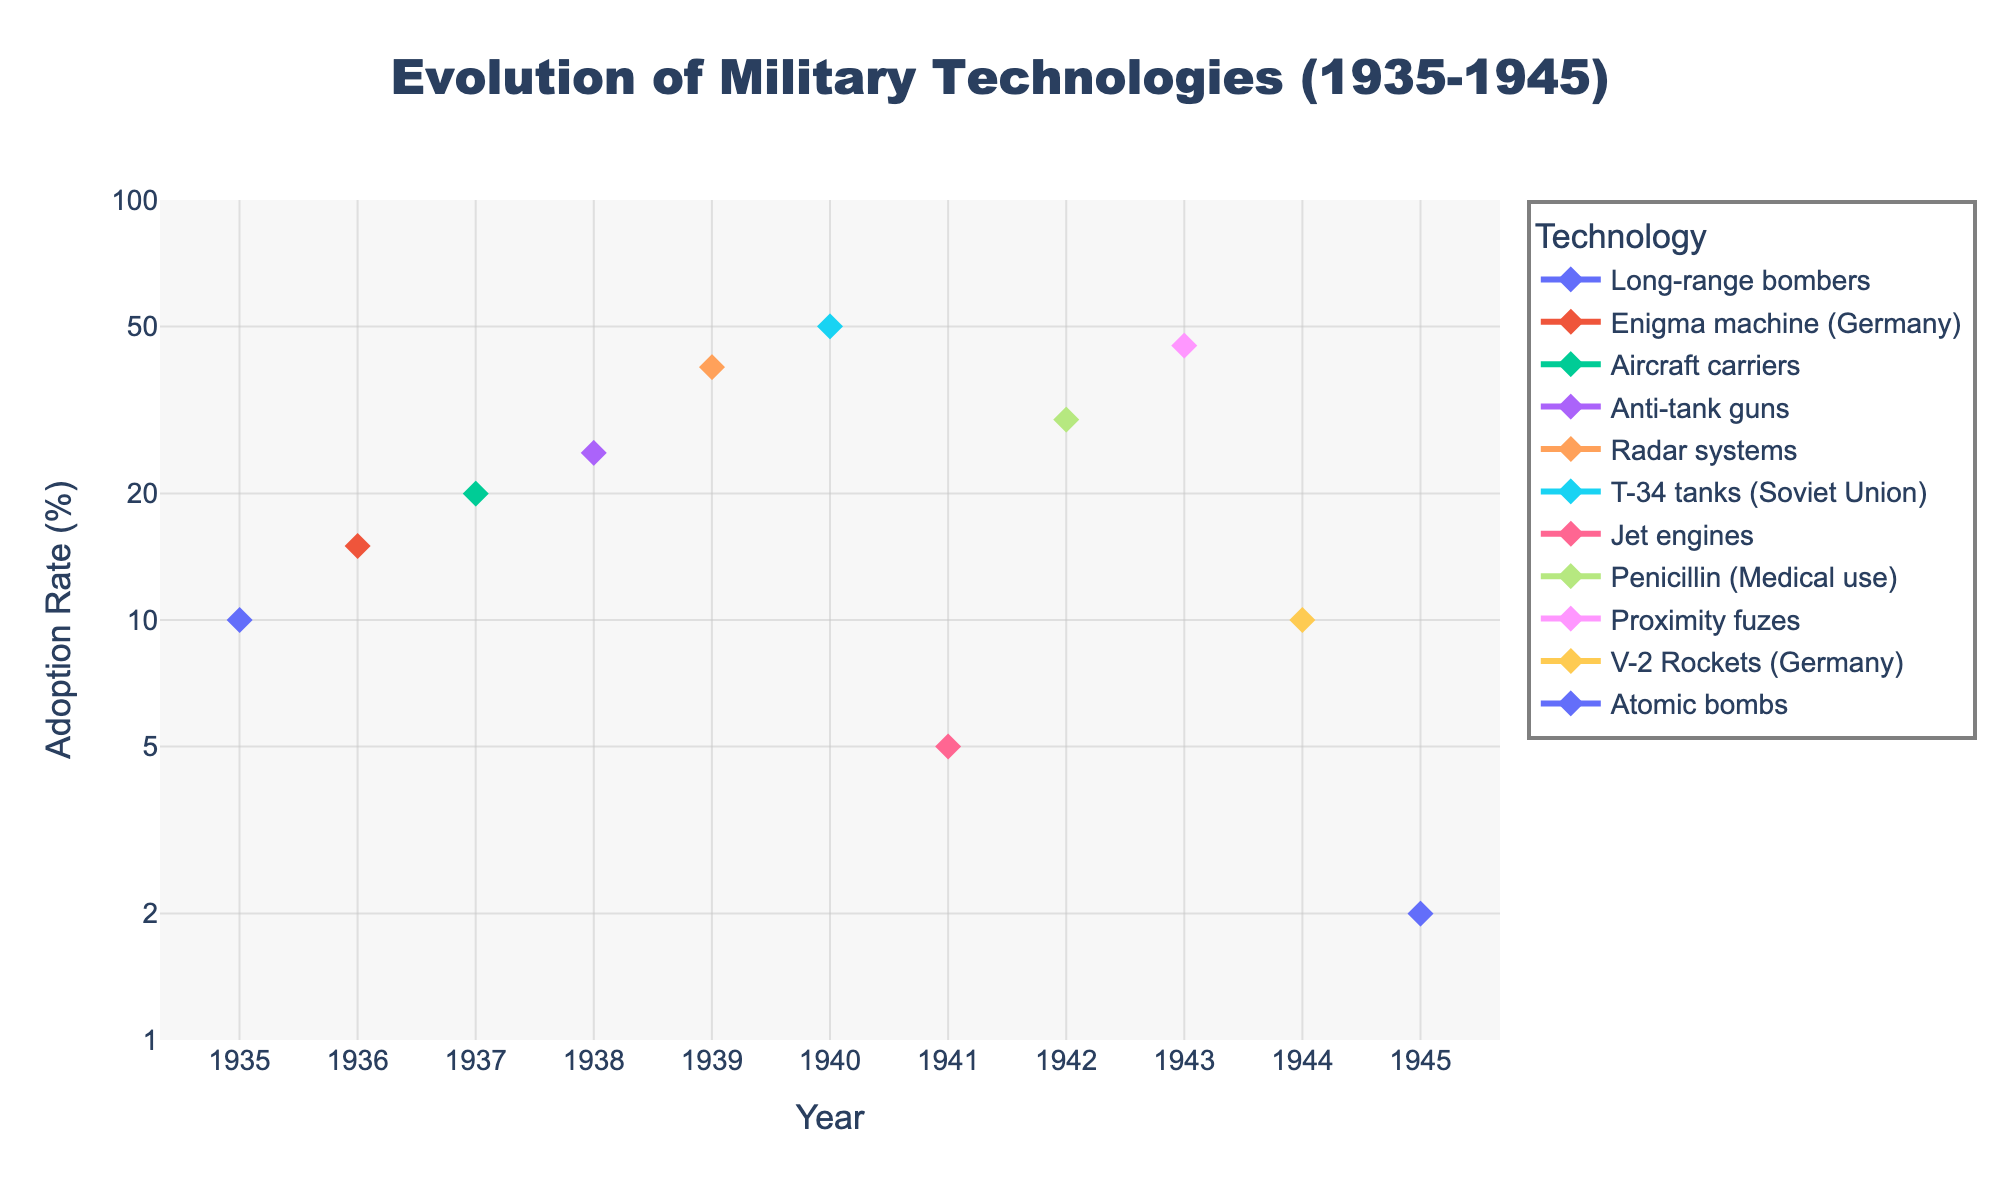What is the title of the figure? The title of the figure is positioned prominently at the top and reads, 'Evolution of Military Technologies (1935-1945)'.
Answer: Evolution of Military Technologies (1935-1945) Which technology had the highest adoption rate in 1940? In 1940, the T-34 tanks (Soviet Union) had the highest adoption rate. This can be identified by checking the adoption rates for all technologies in the year 1940 and noting that T-34 tanks have the maximum value.
Answer: T-34 tanks (Soviet Union) How many technologies are plotted in the figure? The figure shows data for multiple technologies over time. By counting the unique technologies listed, we find there are eleven different technologies.
Answer: Eleven Which technology had an adoption rate of 50% and in which year? By checking the adoption rates, we find that the T-34 tanks (Soviet Union) had an adoption rate of 50%. This occurred in the year 1940.
Answer: T-34 tanks (Soviet Union), 1940 What is the adoption rate of radar systems in 1939? In 1939, radar systems had an adoption rate of 40%. This information is obtained directly from the data list.
Answer: 40% What was the adoption rate of the Enigma machine in 1936, and how does it compare to the adoption rate of V-2 Rockets in 1944? The adoption rate for the Enigma machine in 1936 was 15%. In 1944, the adoption rate for V-2 Rockets was 10%. Comparing the two values, the Enigma machine had a higher adoption rate than V-2 Rockets.
Answer: Enigma machine: 15%, V-2 Rockets: 10% What is the range of the y-axis in this plot? The y-axis uses a logarithmic scale with a range from 1 to 100. This can be checked by examining the y-axis labels and settings.
Answer: 1 to 100 Which year saw the introduction of the atomic bomb, and what was its adoption rate? The figure indicates that the atomic bomb was introduced in 1945 with an adoption rate of 2%. This information is drawn directly from the data.
Answer: 1945, 2% Which technology had the lowest adoption rate, and in which year did this occur? The atomic bomb had the lowest adoption rate of 2%, and this occurred in 1945. By comparing all adoption rates, this value is the smallest.
Answer: Atomic bombs, 1945 Which year had the most technological advancements added to the plot? By checking the data list, we find that multiple technologies were added across different years, but no single year had more than one new technology added. Hence, there is no single year with a peak number of advancements.
Answer: No single year has more than one advancement Between 1941 and 1945, which technological development saw the highest increase in adoption rates? Comparing the adoption rates from 1941 to 1945 for multiple technologies, the Proximity fuzes saw a high rate increase, from an initial introduction (inferred from data) to 45%.
Answer: Proximity fuzes starting from 1943 with an adoption rate of 45 